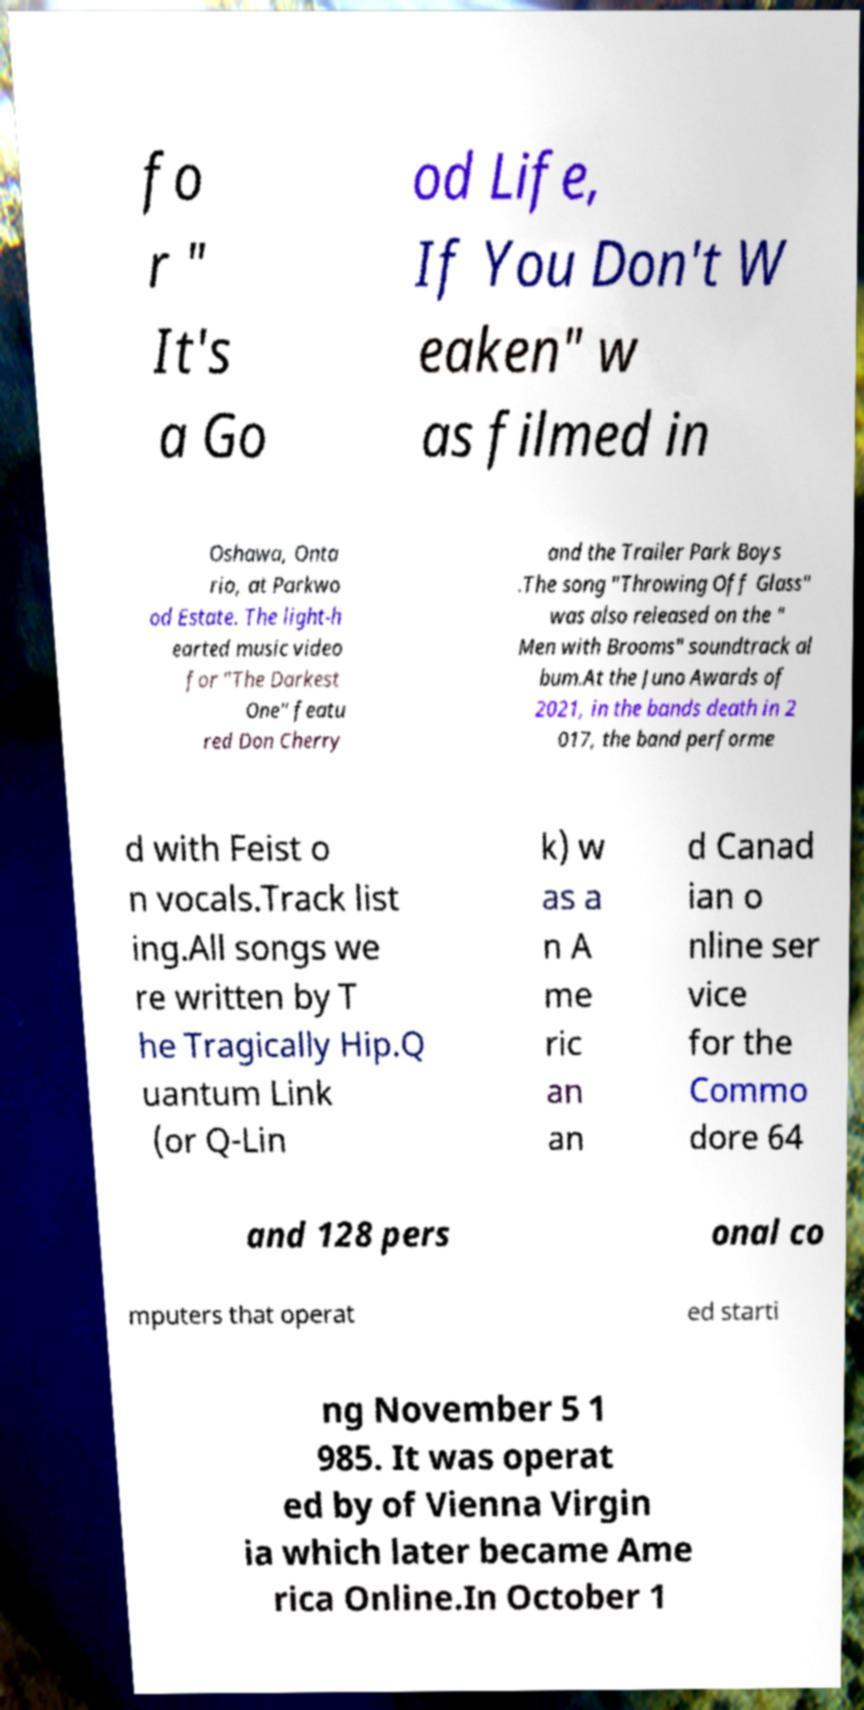Can you accurately transcribe the text from the provided image for me? fo r " It's a Go od Life, If You Don't W eaken" w as filmed in Oshawa, Onta rio, at Parkwo od Estate. The light-h earted music video for "The Darkest One" featu red Don Cherry and the Trailer Park Boys .The song "Throwing Off Glass" was also released on the " Men with Brooms" soundtrack al bum.At the Juno Awards of 2021, in the bands death in 2 017, the band performe d with Feist o n vocals.Track list ing.All songs we re written by T he Tragically Hip.Q uantum Link (or Q-Lin k) w as a n A me ric an an d Canad ian o nline ser vice for the Commo dore 64 and 128 pers onal co mputers that operat ed starti ng November 5 1 985. It was operat ed by of Vienna Virgin ia which later became Ame rica Online.In October 1 